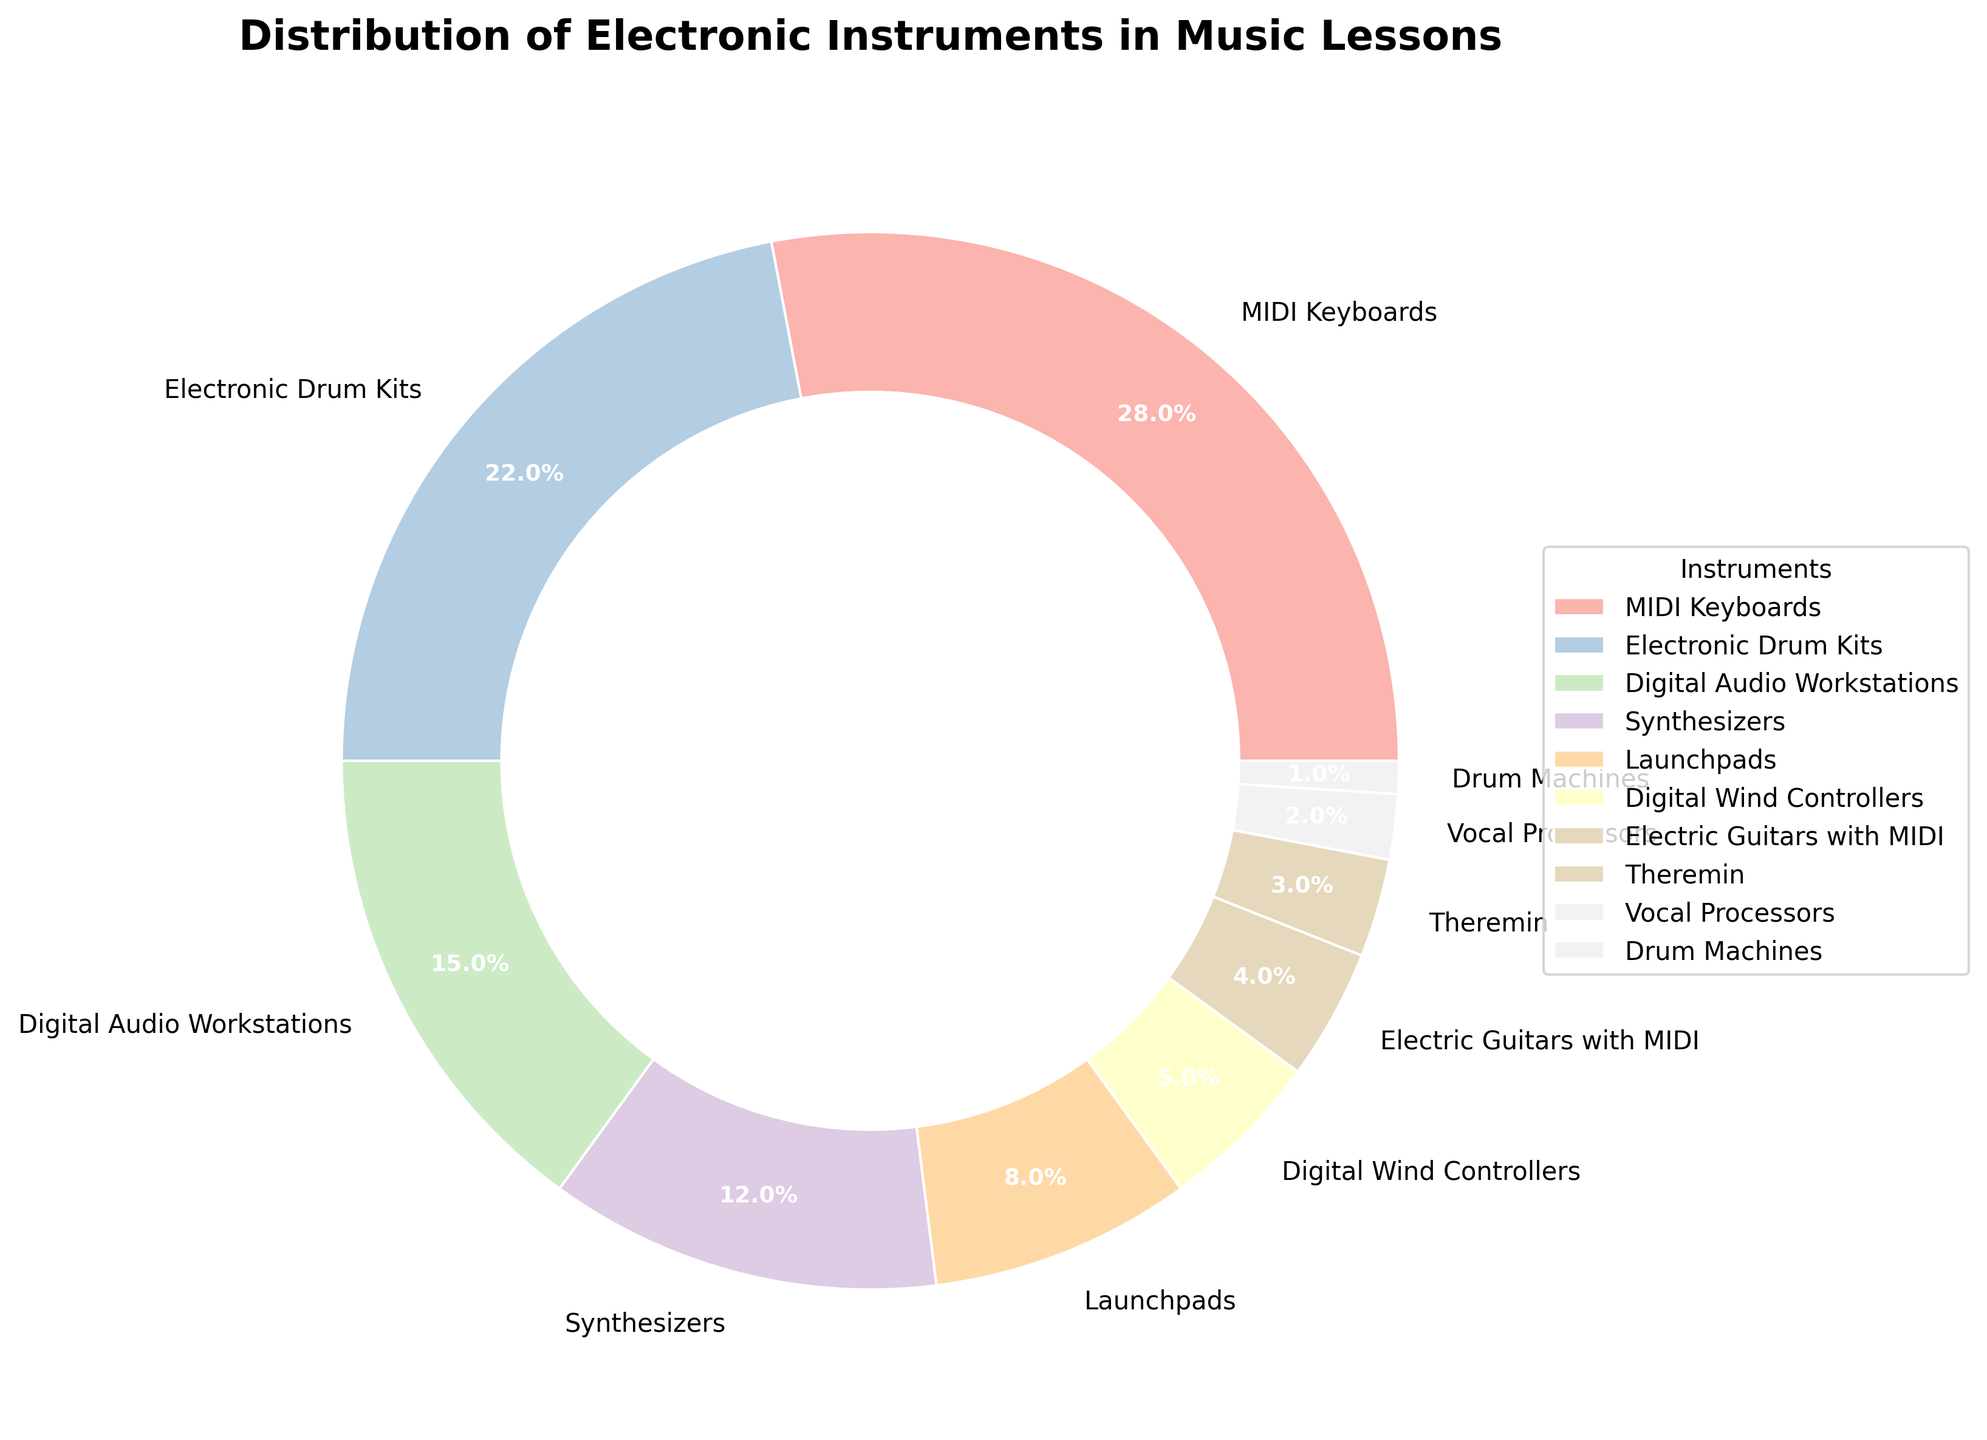Which instrument is the most integrated into music lessons? By examining the pie chart, the largest wedge represents MIDI Keyboards, showing that it is the most integrated instrument.
Answer: MIDI Keyboards What is the combined percentage of Synthesizers and Launchpads? The pie chart shows Synthesizers at 12% and Launchpads at 8%. Summing these percentages gives 12% + 8% = 20%.
Answer: 20% Which instruments are less integrated than Launchpads? The pie chart shows Launchpads at 8%. Instruments with smaller percentages are Digital Wind Controllers (5%), Electric Guitars with MIDI (4%), Theremin (3%), Vocal Processors (2%), and Drum Machines (1%).
Answer: Digital Wind Controllers, Electric Guitars with MIDI, Theremin, Vocal Processors, Drum Machines How does the integration of MIDI Keyboards compare to Digital Audio Workstations? The pie chart shows MIDI Keyboards at 28% and Digital Audio Workstations at 15%. Since 28% is greater than 15%, MIDI Keyboards are more integrated than Digital Audio Workstations.
Answer: MIDI Keyboards are more integrated What is the total percentage of all instruments integrated less than Electronic Drum Kits? Electronic Drum Kits are shown at 22%. Instruments integrated less include Digital Audio Workstations (15%), Synthesizers (12%), Launchpads (8%), Digital Wind Controllers (5%), Electric Guitars with MIDI (4%), Theremin (3%), Vocal Processors (2%), and Drum Machines (1%). Summing these gives 15% + 12% + 8% + 5% + 4% + 3% + 2% + 1% = 50%.
Answer: 50% Compare the integration of Digital Wind Controllers and Vocal Processors The pie chart shows Digital Wind Controllers at 5% and Vocal Processors at 2%. Since 5% is greater than 2%, Digital Wind Controllers are more integrated than Vocal Processors.
Answer: Digital Wind Controllers are more integrated Which instrument takes less than 5% of the distribution and is still higher than Theremin? Looking at the pie chart, Theremin is 3% and the instrument less than 5% but more than Theremin is Electric Guitars with MIDI at 4%.
Answer: Electric Guitars with MIDI Calculate the average percentage of integration for Digital Audio Workstations, Synthesizers, and Launchpads. The percentages provided for these instruments are Digital Audio Workstations (15%), Synthesizers (12%), and Launchpads (8%). Average = (15% + 12% + 8%) / 3 = 35% / 3 ≈ 11.67%.
Answer: 11.67% How much higher in percentage is the most integrated instrument compared to the least integrated one? MIDI Keyboards are at 28% and Drum Machines at 1%. The difference is 28% - 1% = 27%.
Answer: 27% 